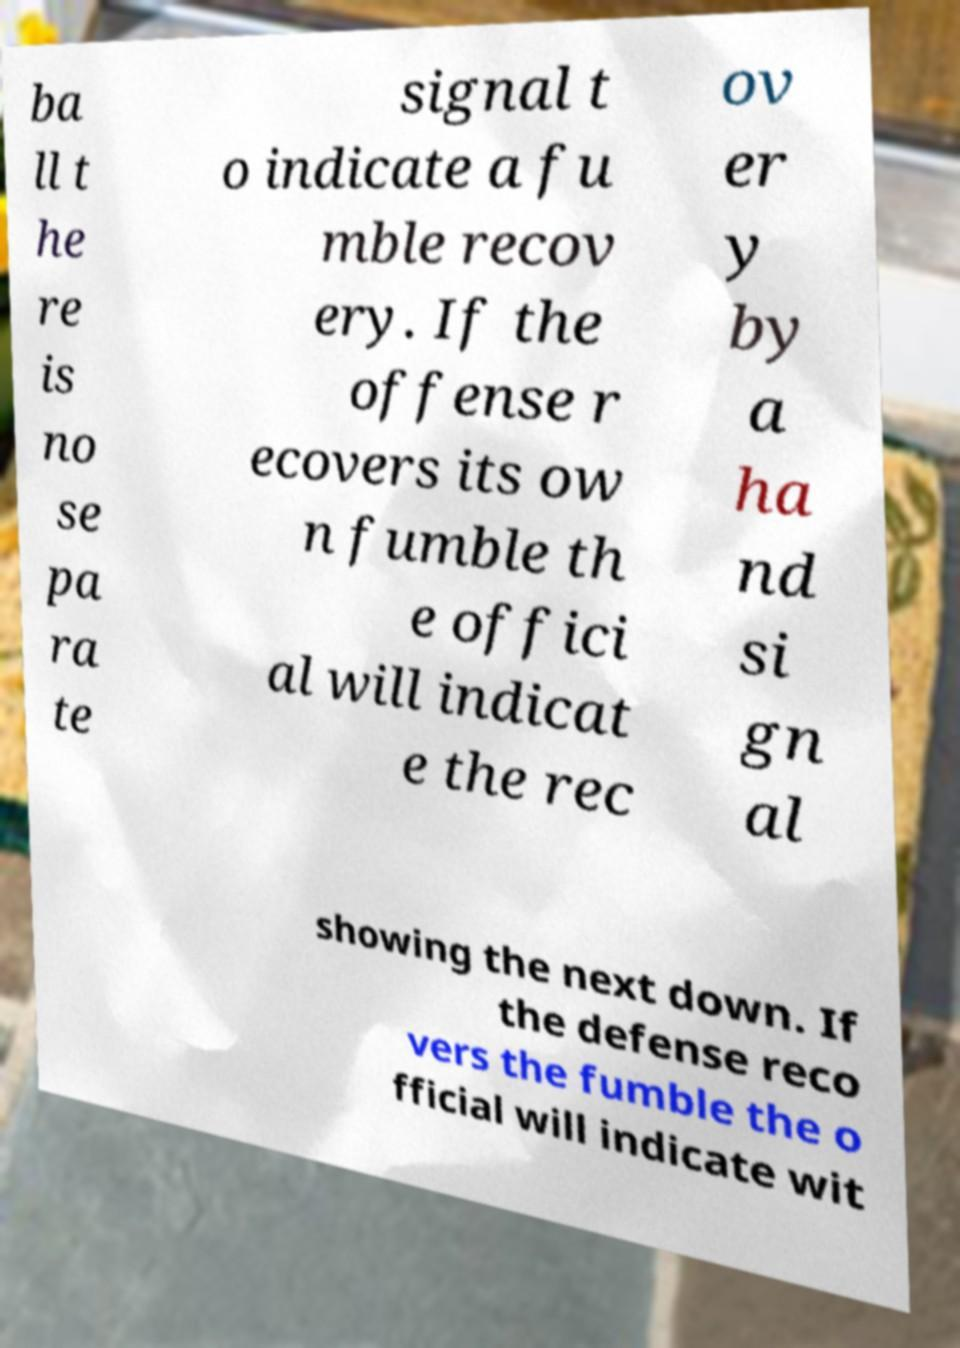Can you accurately transcribe the text from the provided image for me? ba ll t he re is no se pa ra te signal t o indicate a fu mble recov ery. If the offense r ecovers its ow n fumble th e offici al will indicat e the rec ov er y by a ha nd si gn al showing the next down. If the defense reco vers the fumble the o fficial will indicate wit 